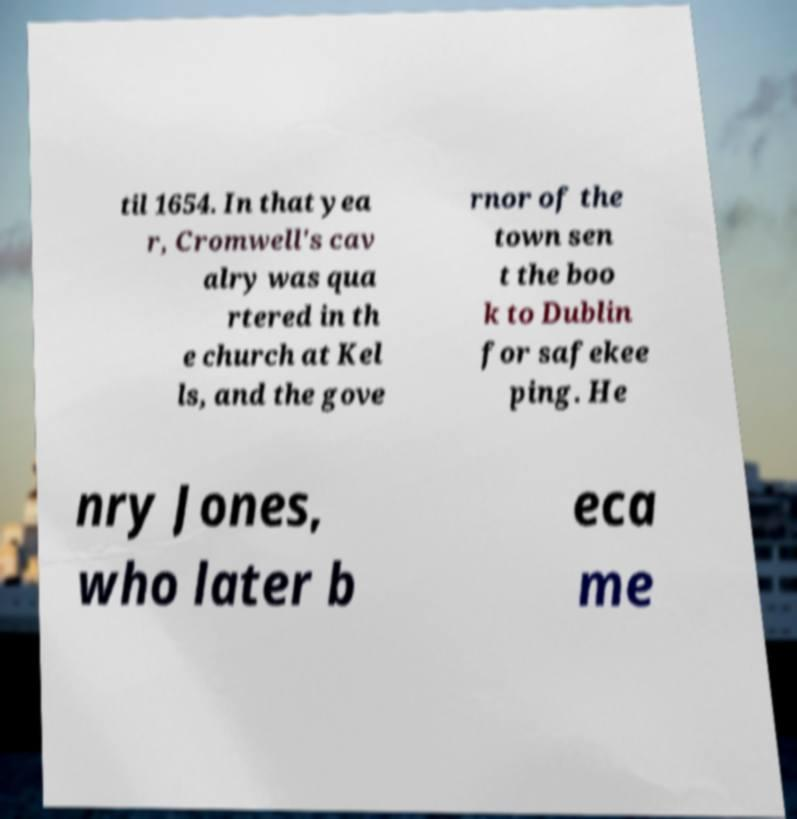Can you read and provide the text displayed in the image?This photo seems to have some interesting text. Can you extract and type it out for me? til 1654. In that yea r, Cromwell's cav alry was qua rtered in th e church at Kel ls, and the gove rnor of the town sen t the boo k to Dublin for safekee ping. He nry Jones, who later b eca me 